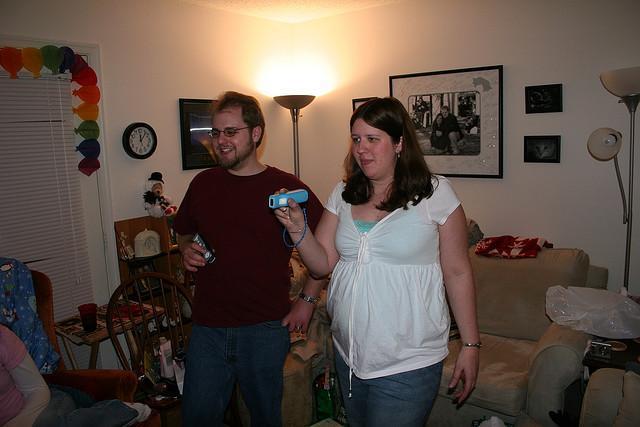How many people are in this picture?
Give a very brief answer. 2. How many people are wearing hats?
Give a very brief answer. 0. How many people are in the photo?
Give a very brief answer. 2. How many people are wearing glasses in this scene?
Give a very brief answer. 1. How many toolbars do you see?
Give a very brief answer. 0. How many people have their hands raised above their shoulders?
Give a very brief answer. 0. How many women are in this photo?
Give a very brief answer. 1. How many people are in this photo?
Give a very brief answer. 2. How many kids are there?
Give a very brief answer. 0. How many cards are attached to the curtain?
Give a very brief answer. 11. How many people are visible?
Give a very brief answer. 3. How many males do you see?
Give a very brief answer. 1. How many chairs are there?
Give a very brief answer. 2. How many people are there?
Give a very brief answer. 3. 